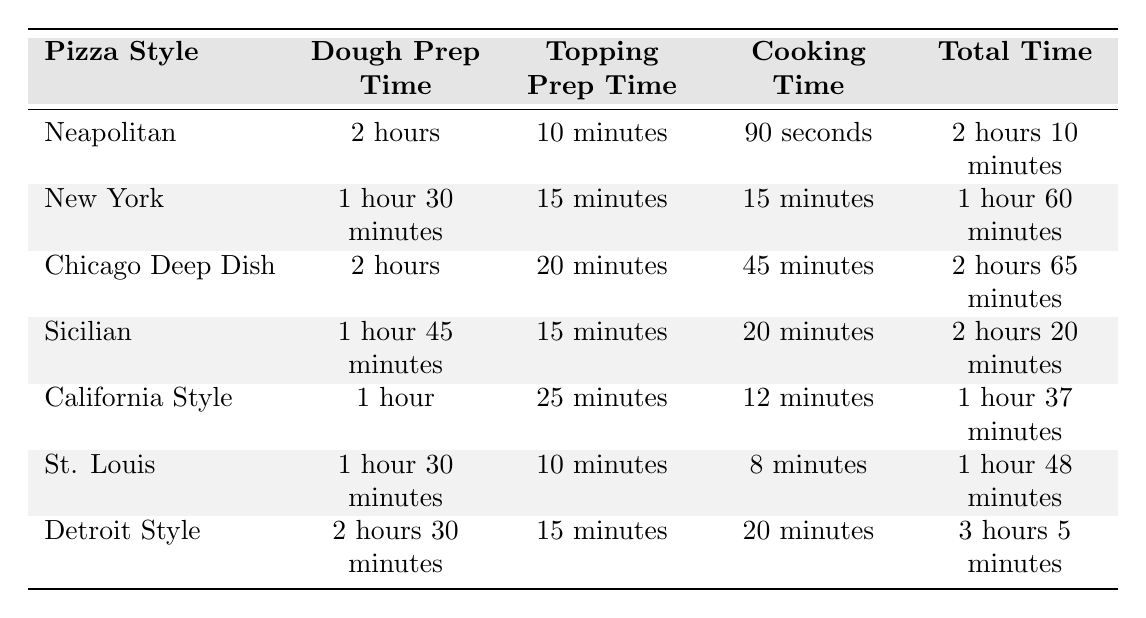What is the cooking time for Neapolitan pizza? The table indicates that the cooking time for Neapolitan pizza is listed as 90 seconds.
Answer: 90 seconds What is the total preparation time for Chicago Deep Dish pizza? The total preparation time is directly given in the table as 2 hours 65 minutes.
Answer: 2 hours 65 minutes Which pizza style has the shortest dough preparation time? By comparing the dough preparation times listed, California Style has the shortest time at 1 hour.
Answer: California Style How much longer does it take to prepare a Detroit Style pizza compared to a New York pizza? The total time for Detroit Style is 3 hours 5 minutes and for New York it is 1 hour 60 minutes. Calculating the difference, 3 hours 5 minutes - 1 hour 60 minutes = 1 hour 5 minutes.
Answer: 1 hour 5 minutes Is the topping preparation time for Sicilian pizza longer than for St. Louis pizza? The topping prep time for Sicilian is 15 minutes, while for St. Louis it is 10 minutes, confirming that Sicilian's time is longer.
Answer: Yes What is the combined dough and topping preparation time for New York pizza? The dough prep time for New York is 1 hour 30 minutes and the topping prep time is 15 minutes. Adding these gives 1 hour 30 minutes + 15 minutes = 1 hour 45 minutes.
Answer: 1 hour 45 minutes Which pizza style requires the most time in total? By reviewing the total time values, Detroit Style with a total of 3 hours 5 minutes is found to be the highest.
Answer: Detroit Style What is the average cooking time of all the pizzas listed? The cooking times are 90 seconds, 15 minutes, 45 minutes, 20 minutes, 12 minutes, 8 minutes, and 20 minutes, converting these to a consistent unit (seconds) leads to an average. The total cooking time in seconds is 90 + 900 + 2700 + 1200 + 720 + 480 + 1200 = 5790 seconds, which averages out to 5790 seconds / 7 = approximately 827 seconds or 13 minutes 47 seconds.
Answer: Approximately 13 minutes 47 seconds How many more minutes does a Chicago Deep Dish pizza take to prepare than a California Style pizza? The total time for Chicago Deep Dish is 2 hours 65 minutes (or 3 hours 5 minutes) and for California Style it is 1 hour 37 minutes. Converting both to minutes: 185 minutes (Chicago) - 97 minutes (California) = 88 minutes.
Answer: 88 minutes 